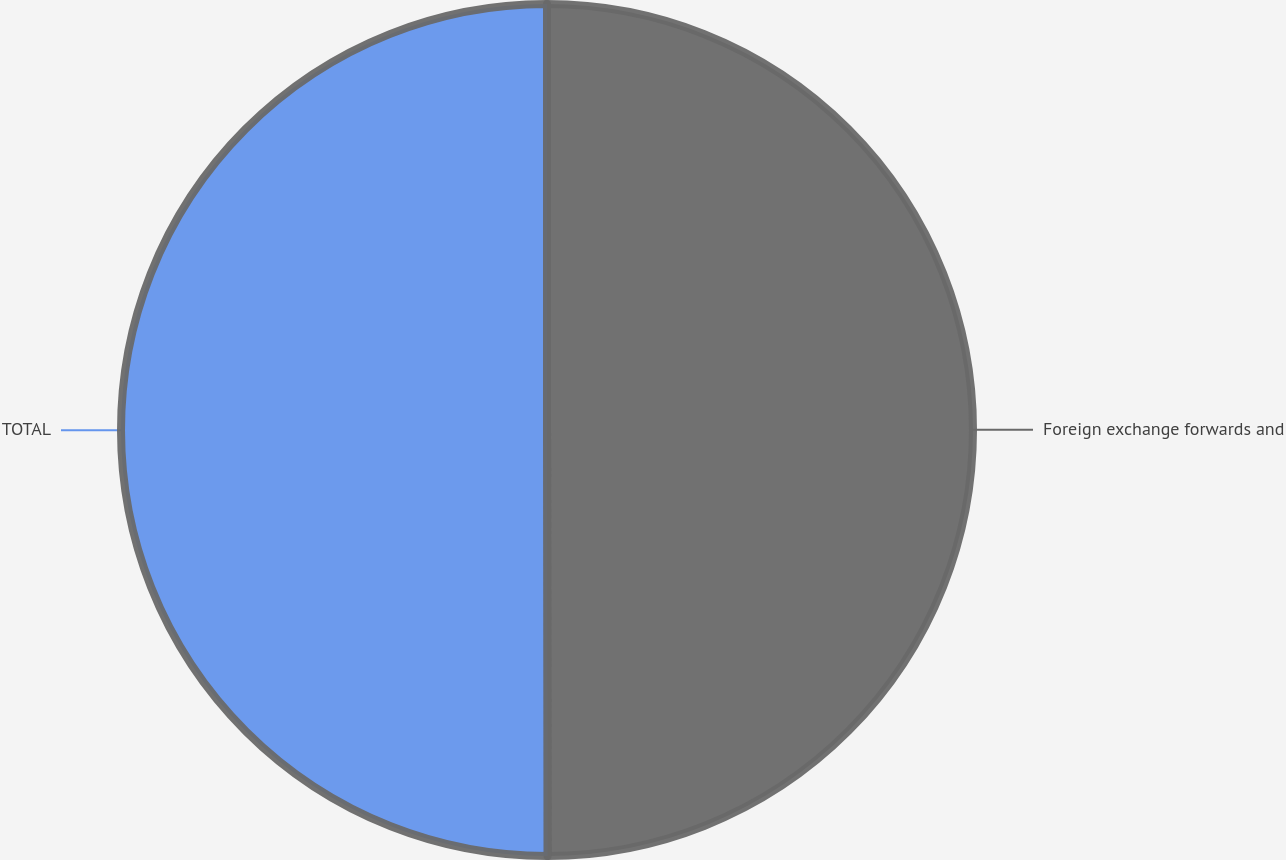Convert chart. <chart><loc_0><loc_0><loc_500><loc_500><pie_chart><fcel>Foreign exchange forwards and<fcel>TOTAL<nl><fcel>49.98%<fcel>50.02%<nl></chart> 